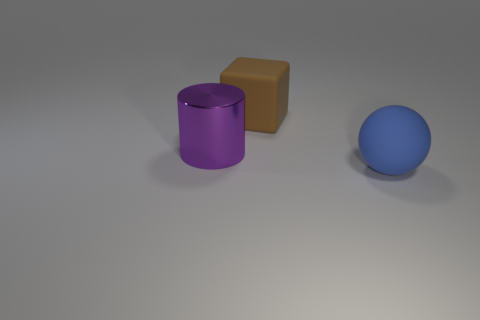Add 2 tiny red metallic objects. How many objects exist? 5 Subtract all big matte cylinders. Subtract all metallic things. How many objects are left? 2 Add 1 large brown rubber objects. How many large brown rubber objects are left? 2 Add 3 gray shiny cylinders. How many gray shiny cylinders exist? 3 Subtract 0 green cylinders. How many objects are left? 3 Subtract all cylinders. How many objects are left? 2 Subtract all red spheres. Subtract all purple blocks. How many spheres are left? 1 